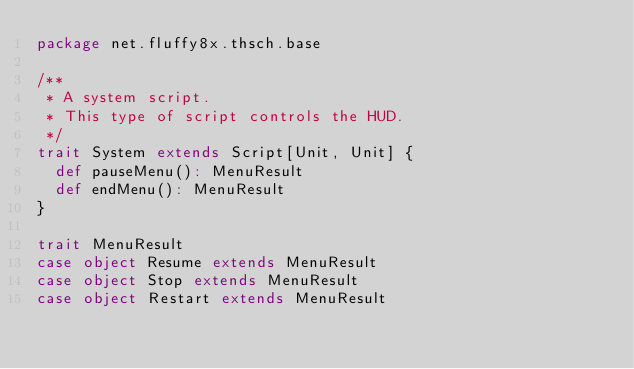Convert code to text. <code><loc_0><loc_0><loc_500><loc_500><_Scala_>package net.fluffy8x.thsch.base

/**
 * A system script.
 * This type of script controls the HUD.
 */
trait System extends Script[Unit, Unit] {
  def pauseMenu(): MenuResult
  def endMenu(): MenuResult
}

trait MenuResult
case object Resume extends MenuResult
case object Stop extends MenuResult
case object Restart extends MenuResult</code> 